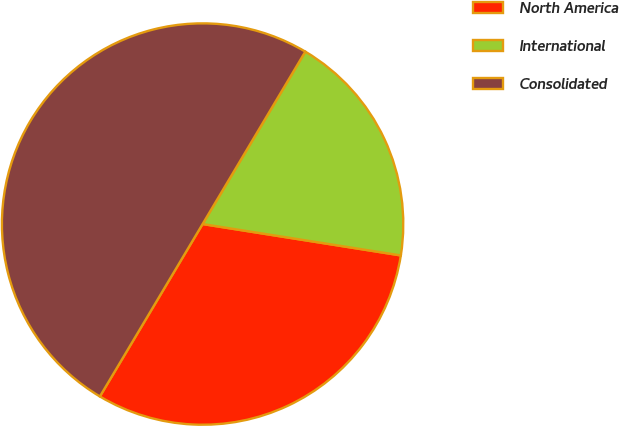Convert chart to OTSL. <chart><loc_0><loc_0><loc_500><loc_500><pie_chart><fcel>North America<fcel>International<fcel>Consolidated<nl><fcel>31.05%<fcel>18.95%<fcel>50.0%<nl></chart> 